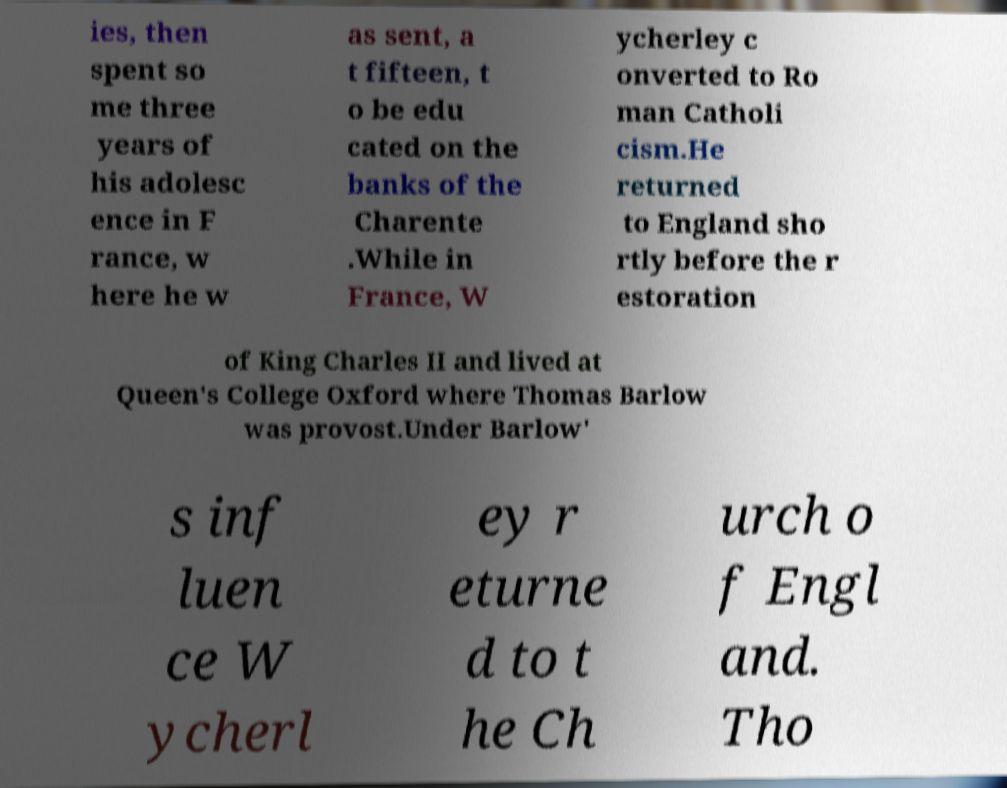What messages or text are displayed in this image? I need them in a readable, typed format. ies, then spent so me three years of his adolesc ence in F rance, w here he w as sent, a t fifteen, t o be edu cated on the banks of the Charente .While in France, W ycherley c onverted to Ro man Catholi cism.He returned to England sho rtly before the r estoration of King Charles II and lived at Queen's College Oxford where Thomas Barlow was provost.Under Barlow' s inf luen ce W ycherl ey r eturne d to t he Ch urch o f Engl and. Tho 